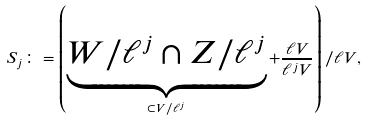<formula> <loc_0><loc_0><loc_500><loc_500>S _ { j } \colon = \left ( \underbrace { W / \ell ^ { j } \cap Z / \ell ^ { j } } _ { \subset V / \ell ^ { j } } + \frac { \ell V } { \ell ^ { j } V } \right ) / \ell V ,</formula> 